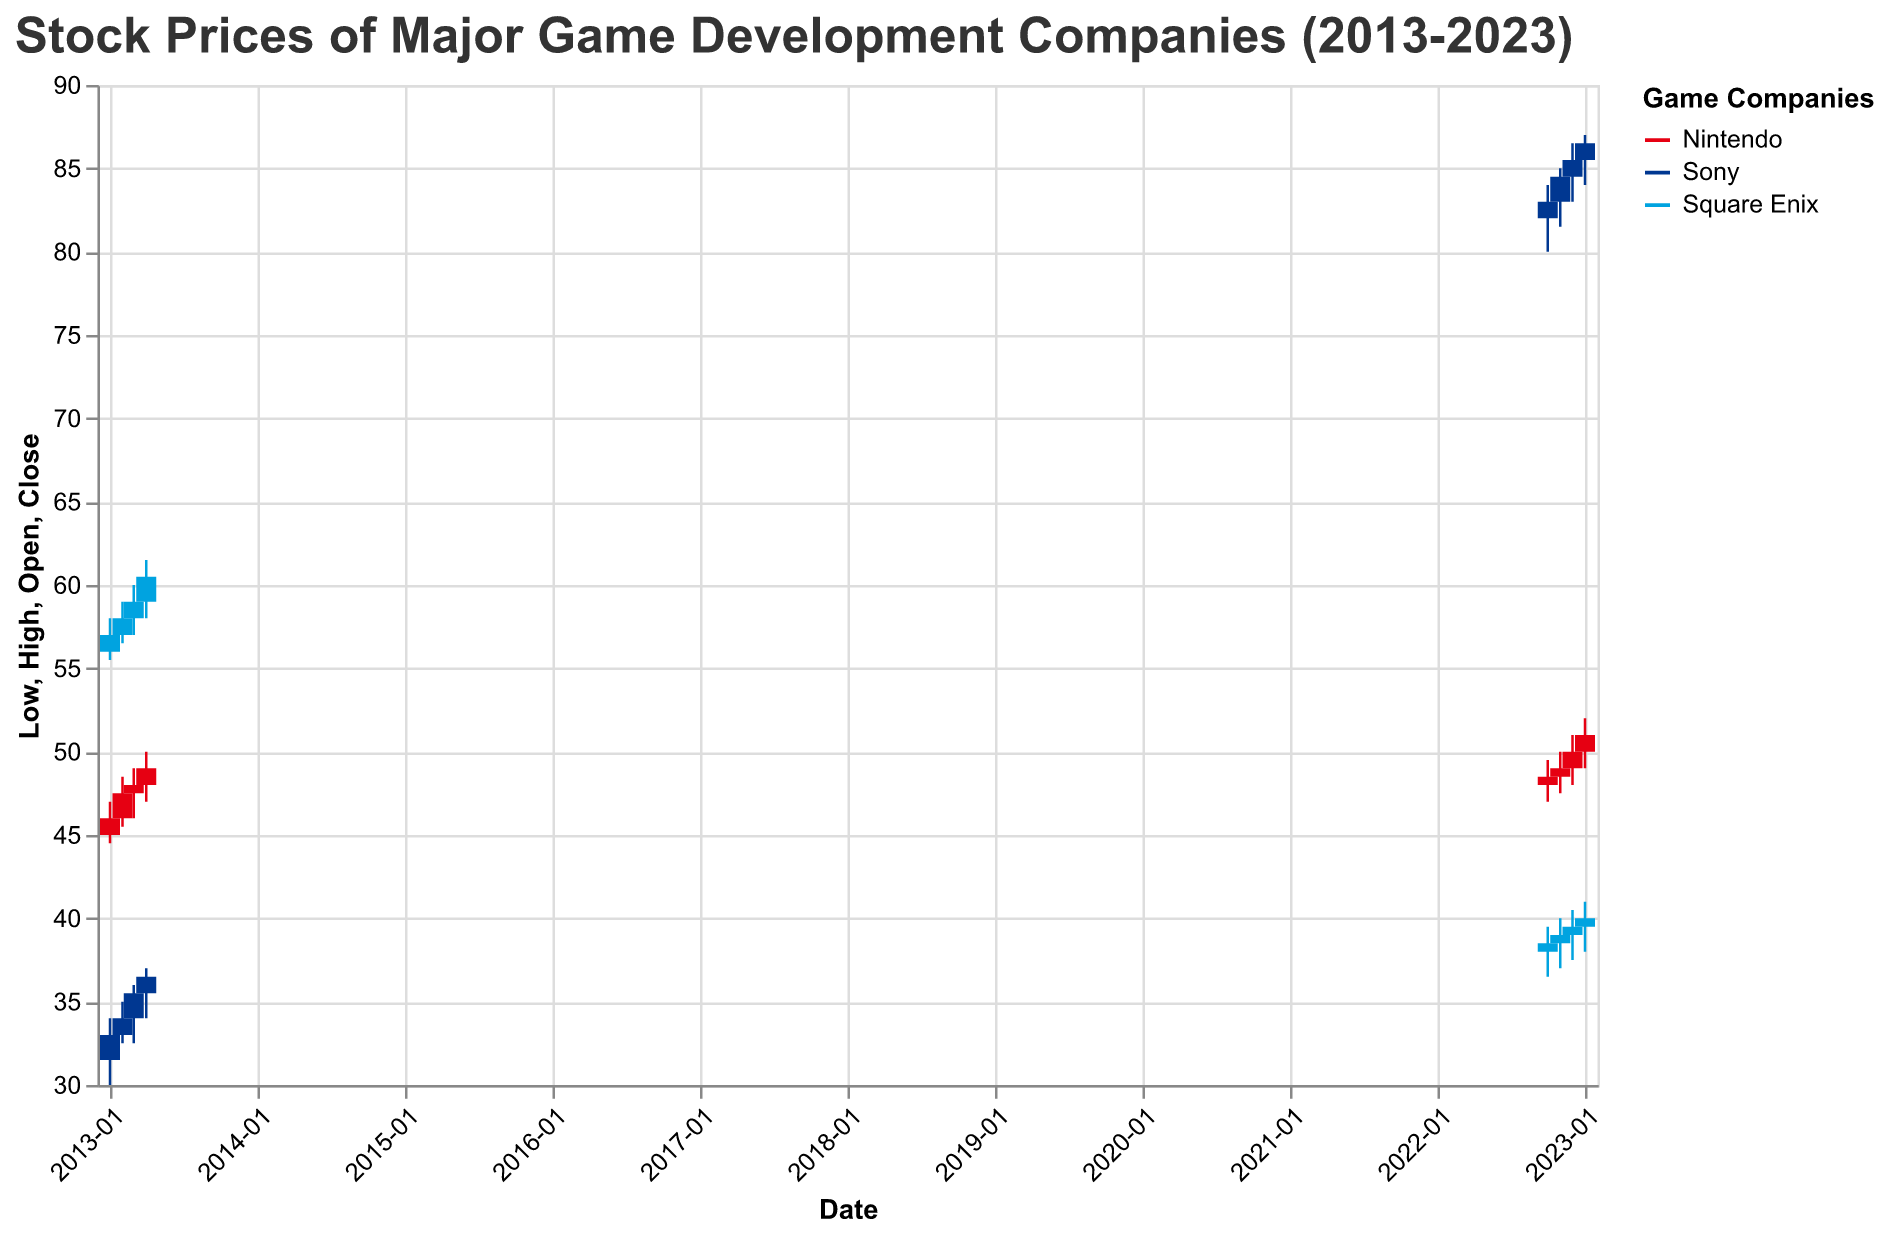What is the title of the figure? The title is located at the top of the figure and provides a summary of what the chart is about. Reading the title directly gives us this information.
Answer: Stock Prices of Major Game Development Companies (2013-2023) What companies are included in the figure? The legend indicates the companies included, which are defining the colors for the lines and bars in the chart.
Answer: Nintendo, Sony, Square Enix What is the color used for Sony in the chart? The legend assigns colors to each company. The color for Sony is displayed in the legend.
Answer: Blue What was Sony's closing stock price in October 2022? By locating the date "2022-10-01" on the x-axis and finding the corresponding bar for Sony, we can read off the closing price.
Answer: 83 Which company had the highest stock price in December 2022? By checking the high value for each company in December 2022, we can determine which company had the highest stock price.
Answer: Sony Which company showed the most consistent stock price growth over the years shown? By comparing the trend lines and candlestick patterns over the time period for each company, one can determine which company had the steadiest increase. Sony shows consistent growth from 2013 to 2023.
Answer: Sony Compare the performance of Samsung and Square Enix at the beginning of the dataset. What do you observe? By examining the opening and closing prices for January and February of 2013 for both companies, it becomes clear which one performed better. Square Enix showed higher and more stable values compared to Sony at the beginning.
Answer: Square Enix performed better What is the overall trend of Sony’s stock price from 2013 to 2023? Analyzing Sony’s stock prices at various points over the period, we can determine whether the stock has generally increased, decreased, or remained stable. Sony’s stock shows a rising trend from 2013 to 2023.
Answer: Increasing trend 